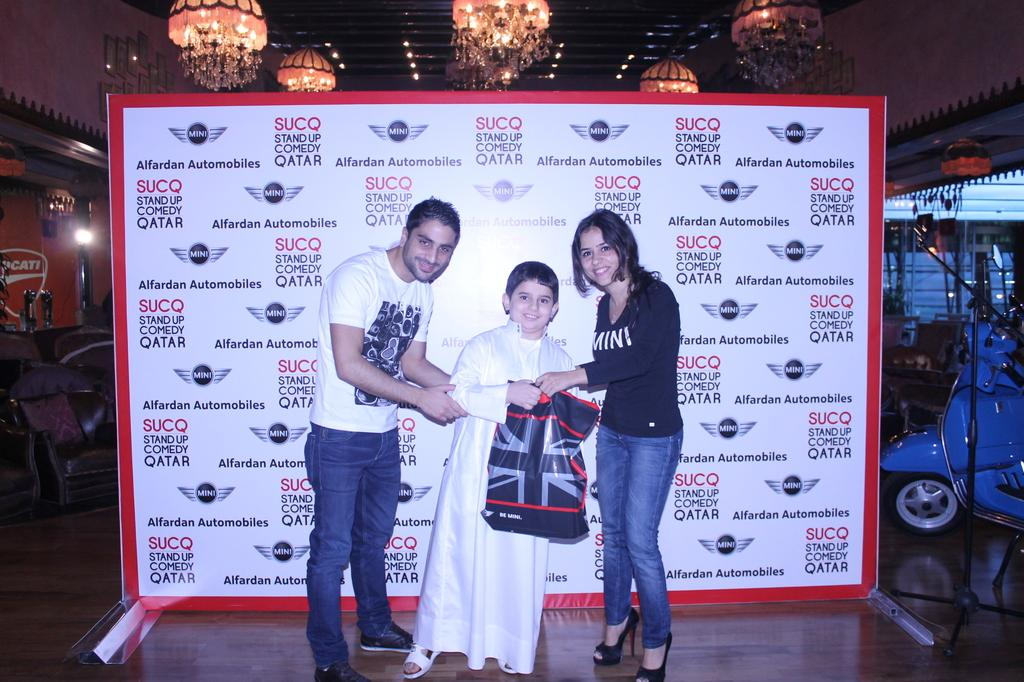<image>
Present a compact description of the photo's key features. A man and a woman pose for a photo with a child in front of a backdrop that says "SUCQ Stand Up Comedy Qatar." 